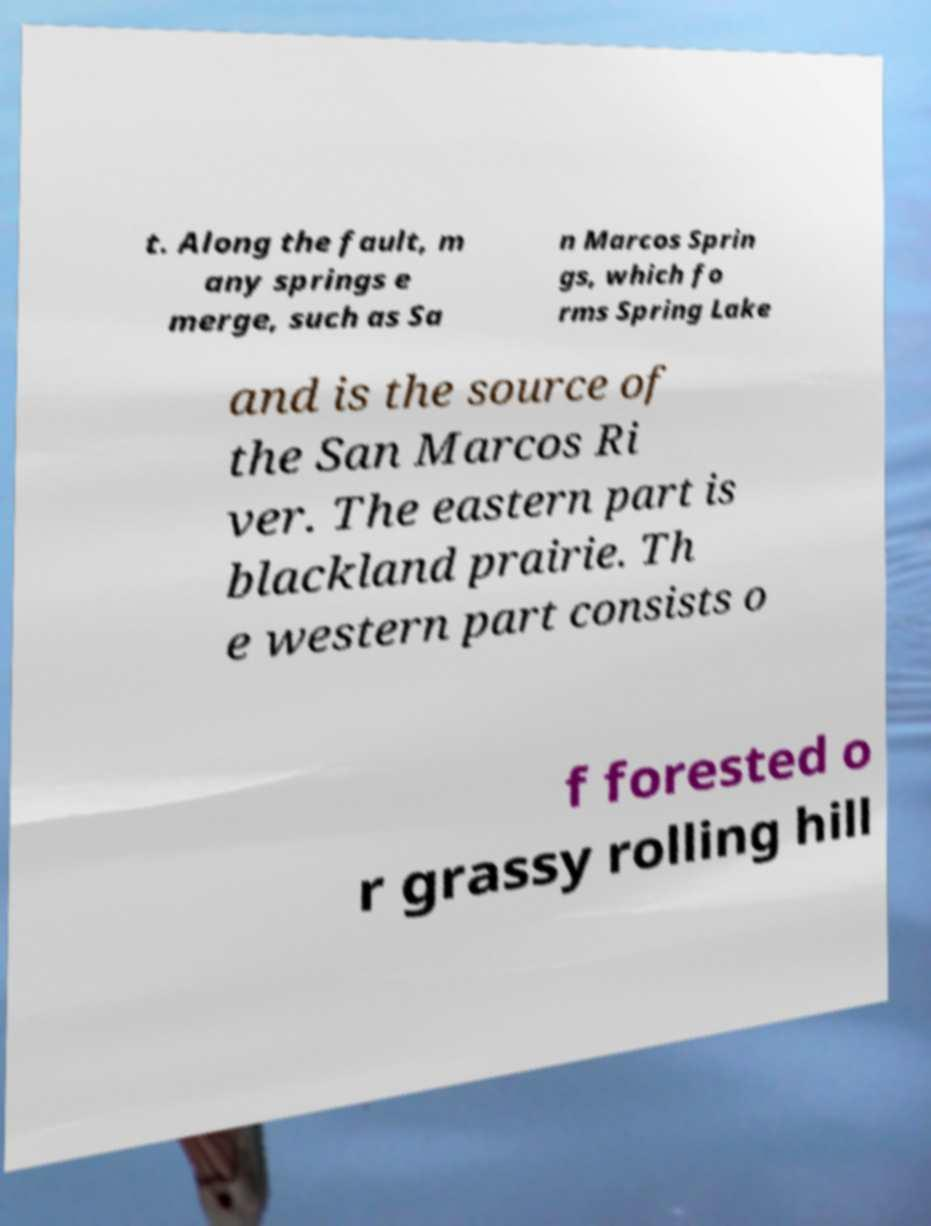There's text embedded in this image that I need extracted. Can you transcribe it verbatim? t. Along the fault, m any springs e merge, such as Sa n Marcos Sprin gs, which fo rms Spring Lake and is the source of the San Marcos Ri ver. The eastern part is blackland prairie. Th e western part consists o f forested o r grassy rolling hill 